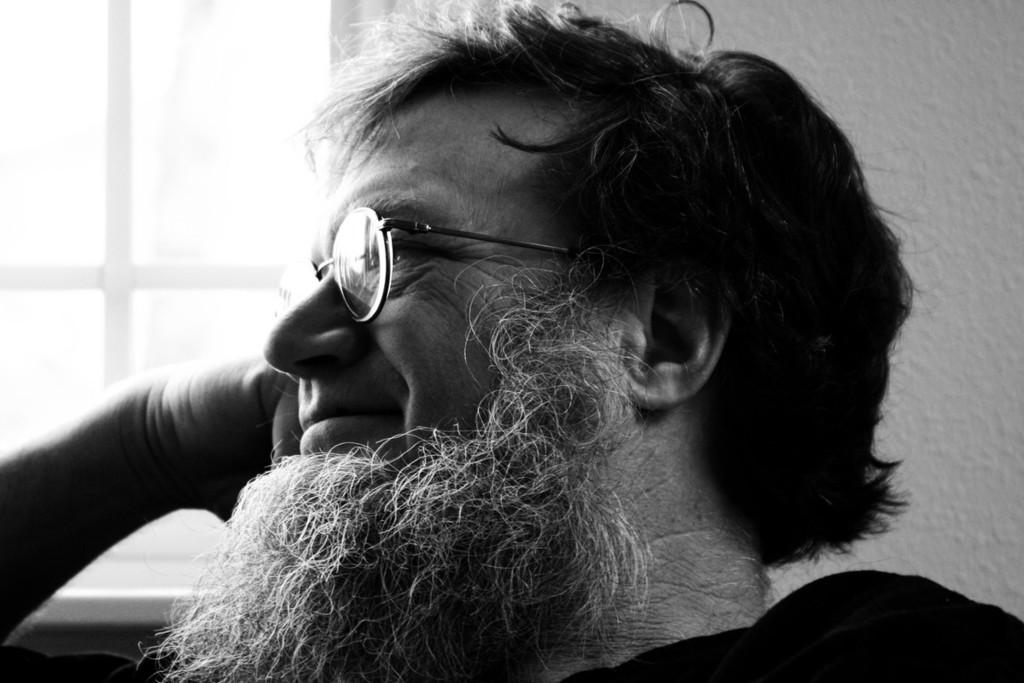What is the color scheme of the image? The image is black and white. Who or what can be seen in the image? There is a man in the image. What type of structure is visible in the image? There is a wall visible in the image. Is there any opening in the wall visible in the image? A: Yes, there is a window in the image. How many pans are being used by the man in the image? There are no pans visible in the image; it is a black and white image of a man with a wall and a window. How many legs does the man have in the image? The image is black and white, and it is not possible to determine the number of legs the man has based on the provided information. 